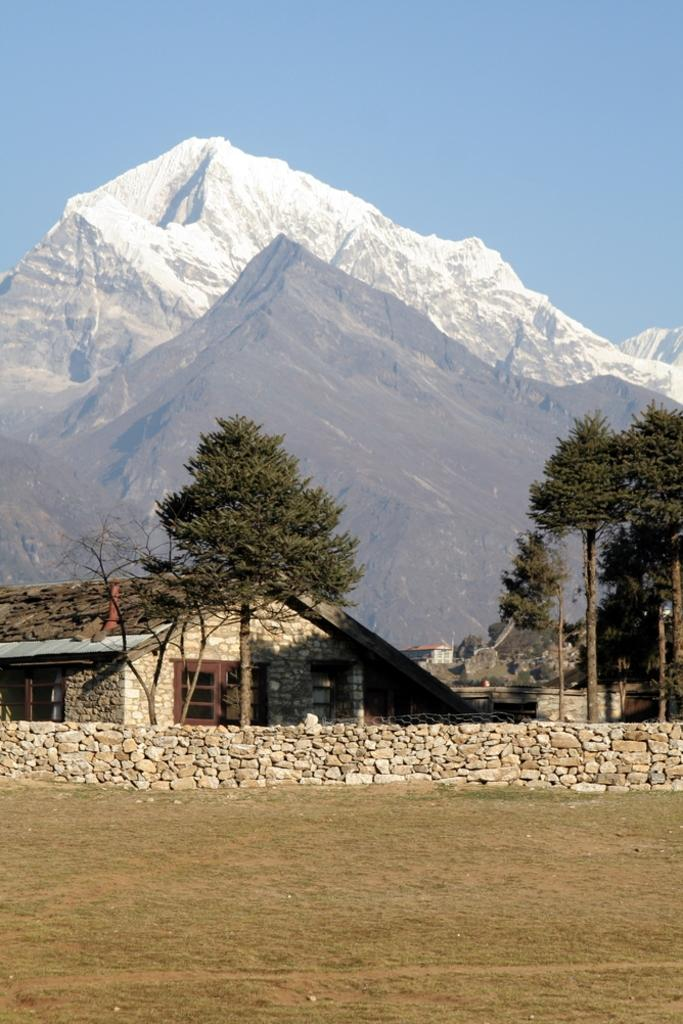What can be seen in the sky in the image? The sky is visible in the image. What type of natural landform is present in the image? There are mountains in the image. What type of vegetation is present in the image? There are trees in the image. How are the trees positioned on the right side of the image? Some trees are truncated towards the right side of the image. What type of structure is present in the image? There is a house in the image. What architectural feature is truncated in the image? There is a wall that is truncated in the image. What type of texture can be seen on the field in the image? There is no field present in the image; it features mountains, trees, a house, and a truncated wall. 